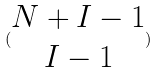Convert formula to latex. <formula><loc_0><loc_0><loc_500><loc_500>( \begin{matrix} N + I - 1 \\ I - 1 \end{matrix} )</formula> 